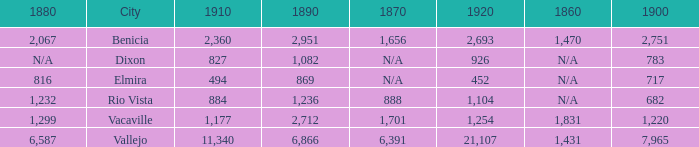What is the 1880 figure when 1860 is N/A and 1910 is 494? 816.0. 